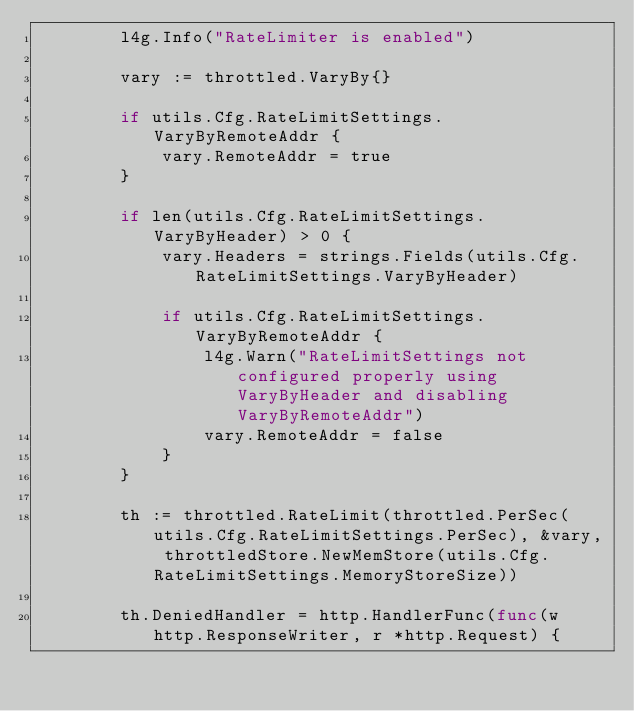Convert code to text. <code><loc_0><loc_0><loc_500><loc_500><_Go_>		l4g.Info("RateLimiter is enabled")

		vary := throttled.VaryBy{}

		if utils.Cfg.RateLimitSettings.VaryByRemoteAddr {
			vary.RemoteAddr = true
		}

		if len(utils.Cfg.RateLimitSettings.VaryByHeader) > 0 {
			vary.Headers = strings.Fields(utils.Cfg.RateLimitSettings.VaryByHeader)

			if utils.Cfg.RateLimitSettings.VaryByRemoteAddr {
				l4g.Warn("RateLimitSettings not configured properly using VaryByHeader and disabling VaryByRemoteAddr")
				vary.RemoteAddr = false
			}
		}

		th := throttled.RateLimit(throttled.PerSec(utils.Cfg.RateLimitSettings.PerSec), &vary, throttledStore.NewMemStore(utils.Cfg.RateLimitSettings.MemoryStoreSize))

		th.DeniedHandler = http.HandlerFunc(func(w http.ResponseWriter, r *http.Request) {</code> 